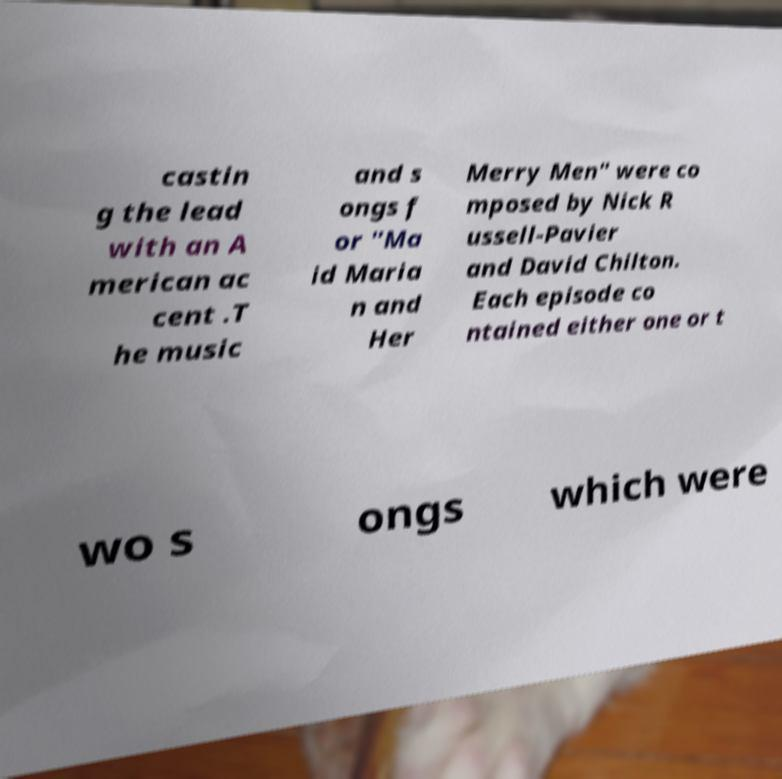Can you read and provide the text displayed in the image?This photo seems to have some interesting text. Can you extract and type it out for me? castin g the lead with an A merican ac cent .T he music and s ongs f or "Ma id Maria n and Her Merry Men" were co mposed by Nick R ussell-Pavier and David Chilton. Each episode co ntained either one or t wo s ongs which were 